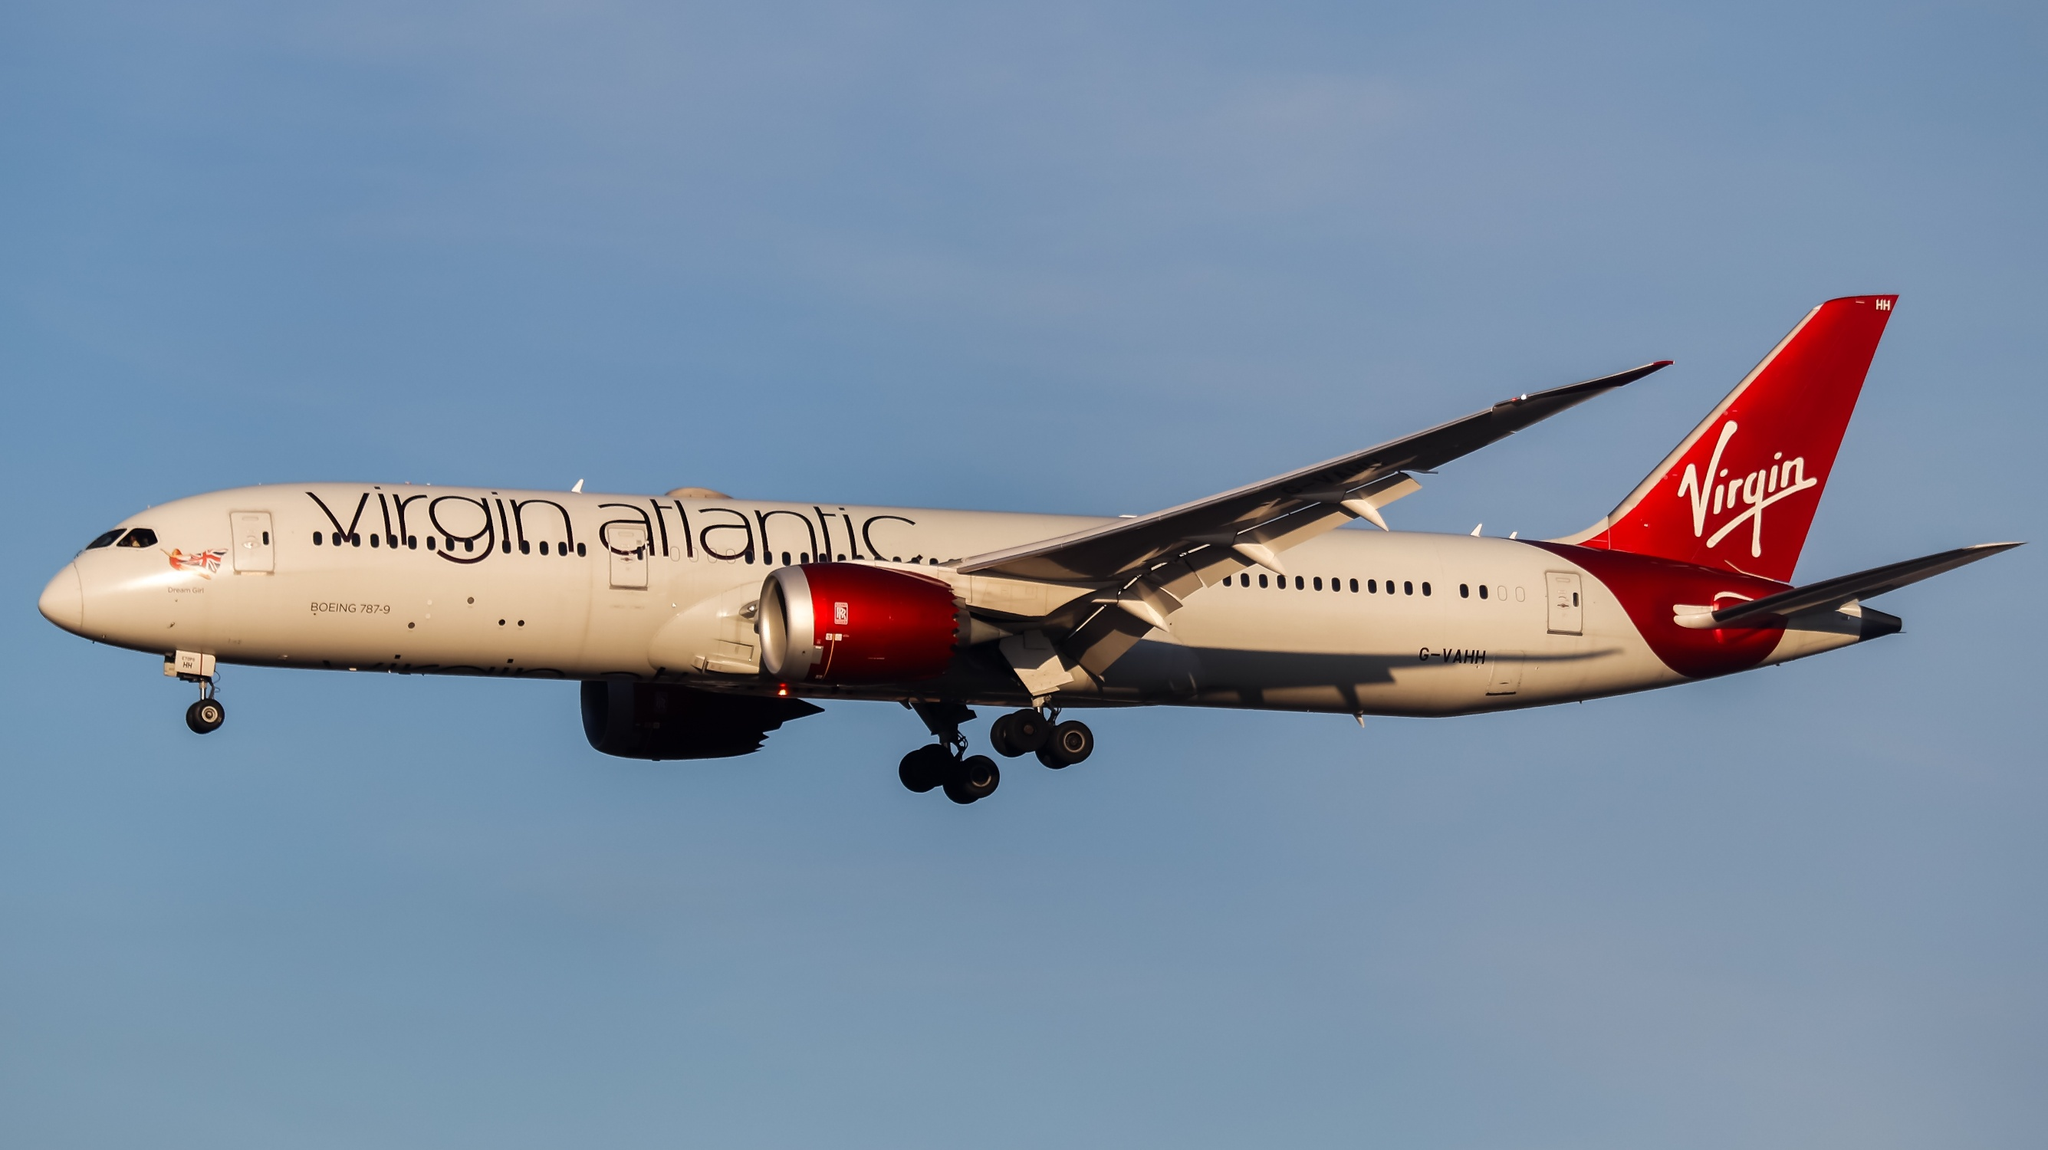What is this photo about? The image captures a majestic moment of a Virgin Atlantic airplane soaring through the serene blue sky. The airplane, specifically a Boeing 787-9 Dreamliner with the registration G-VZIG, stands out with its sleek white fuselage, complemented by a striking red tail and engines. This mid-flight photograph features the aircraft flying smoothly from left to right, with its landing gear retracted. The text 'Virgin Atlantic' is prominently displayed in elegant black letters on the fuselage, while the tail proudly showcases the 'Virgin' brand in white letters. Both engines, painted a vivid red, add to the aircraft's distinctive appearance. This scene beautifully epitomizes the marvels of modern aviation and the elegance of Virgin Atlantic's fleet. 